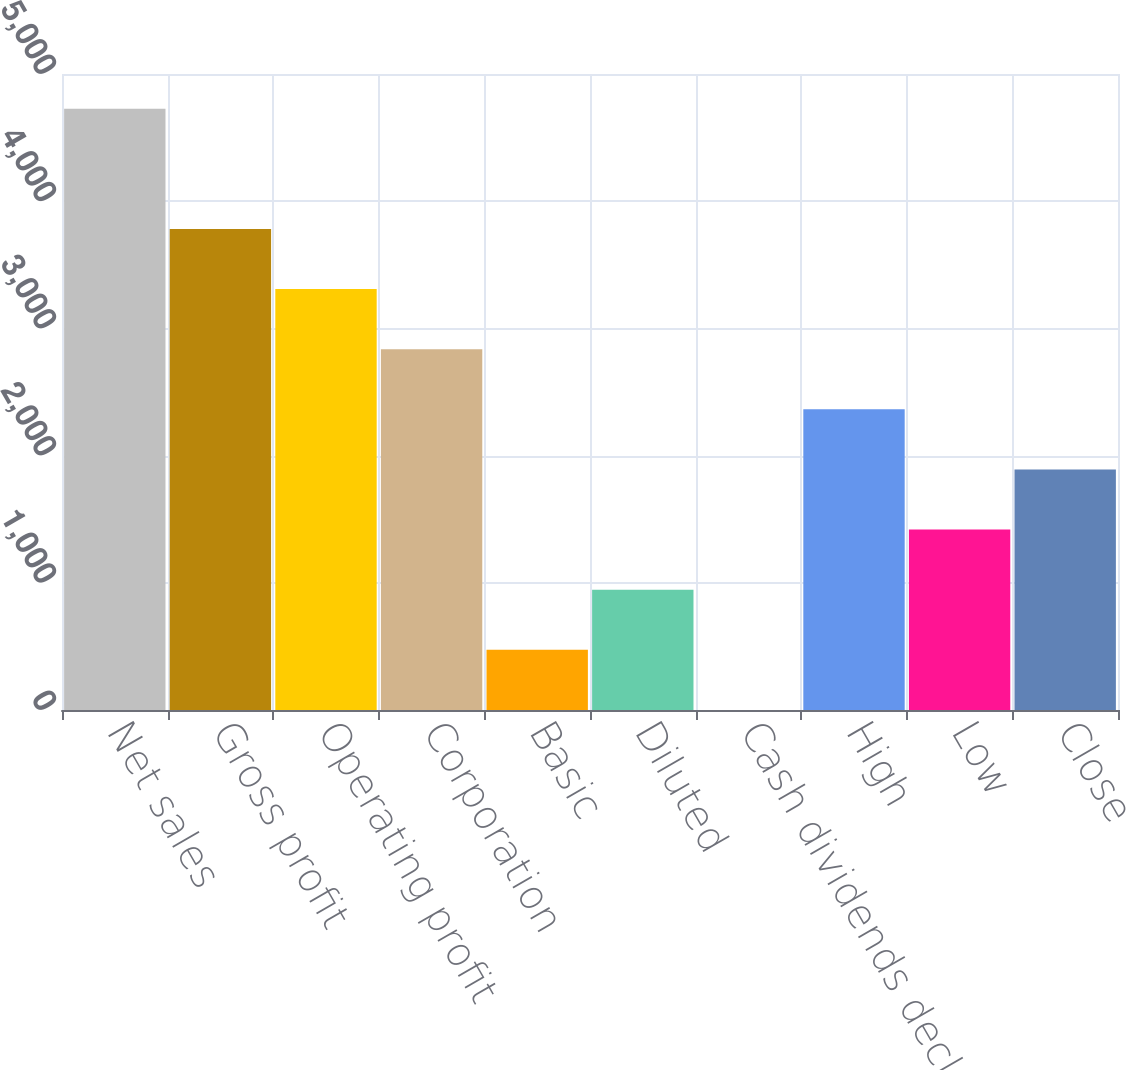<chart> <loc_0><loc_0><loc_500><loc_500><bar_chart><fcel>Net sales<fcel>Gross profit<fcel>Operating profit<fcel>Corporation<fcel>Basic<fcel>Diluted<fcel>Cash dividends declared per<fcel>High<fcel>Low<fcel>Close<nl><fcel>4727<fcel>3781.72<fcel>3309.08<fcel>2836.44<fcel>473.24<fcel>945.88<fcel>0.6<fcel>2363.8<fcel>1418.52<fcel>1891.16<nl></chart> 